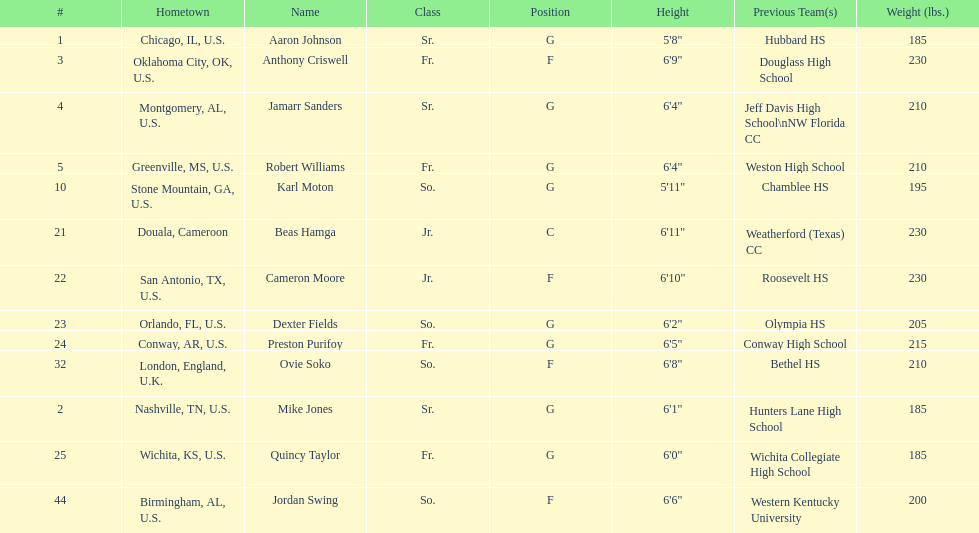What is the difference in weight between dexter fields and quincy taylor? 20. 